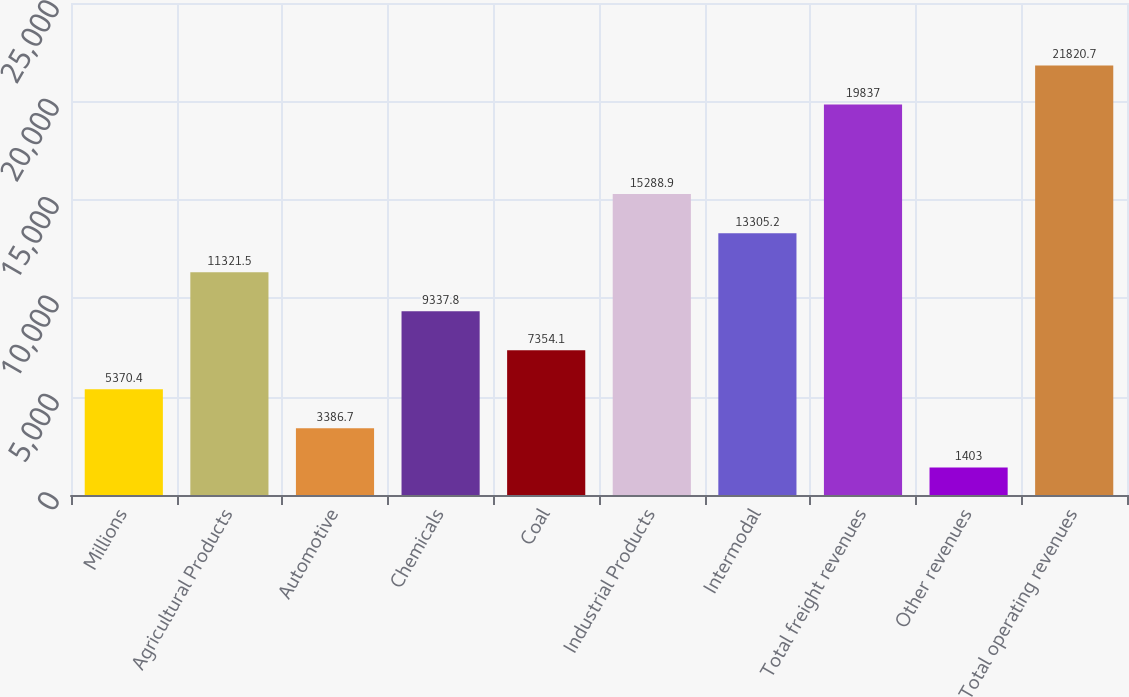Convert chart. <chart><loc_0><loc_0><loc_500><loc_500><bar_chart><fcel>Millions<fcel>Agricultural Products<fcel>Automotive<fcel>Chemicals<fcel>Coal<fcel>Industrial Products<fcel>Intermodal<fcel>Total freight revenues<fcel>Other revenues<fcel>Total operating revenues<nl><fcel>5370.4<fcel>11321.5<fcel>3386.7<fcel>9337.8<fcel>7354.1<fcel>15288.9<fcel>13305.2<fcel>19837<fcel>1403<fcel>21820.7<nl></chart> 